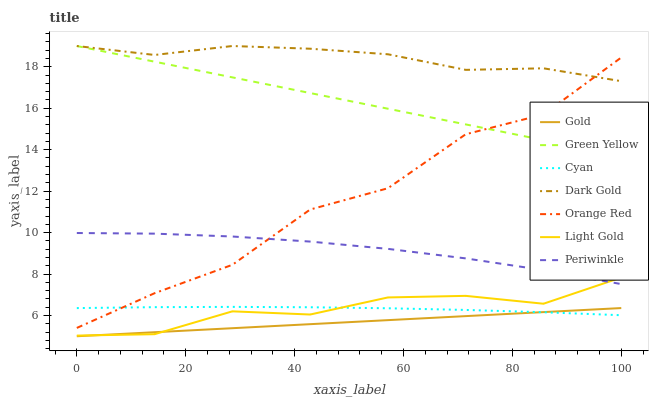Does Periwinkle have the minimum area under the curve?
Answer yes or no. No. Does Periwinkle have the maximum area under the curve?
Answer yes or no. No. Is Dark Gold the smoothest?
Answer yes or no. No. Is Dark Gold the roughest?
Answer yes or no. No. Does Periwinkle have the lowest value?
Answer yes or no. No. Does Periwinkle have the highest value?
Answer yes or no. No. Is Periwinkle less than Green Yellow?
Answer yes or no. Yes. Is Orange Red greater than Gold?
Answer yes or no. Yes. Does Periwinkle intersect Green Yellow?
Answer yes or no. No. 